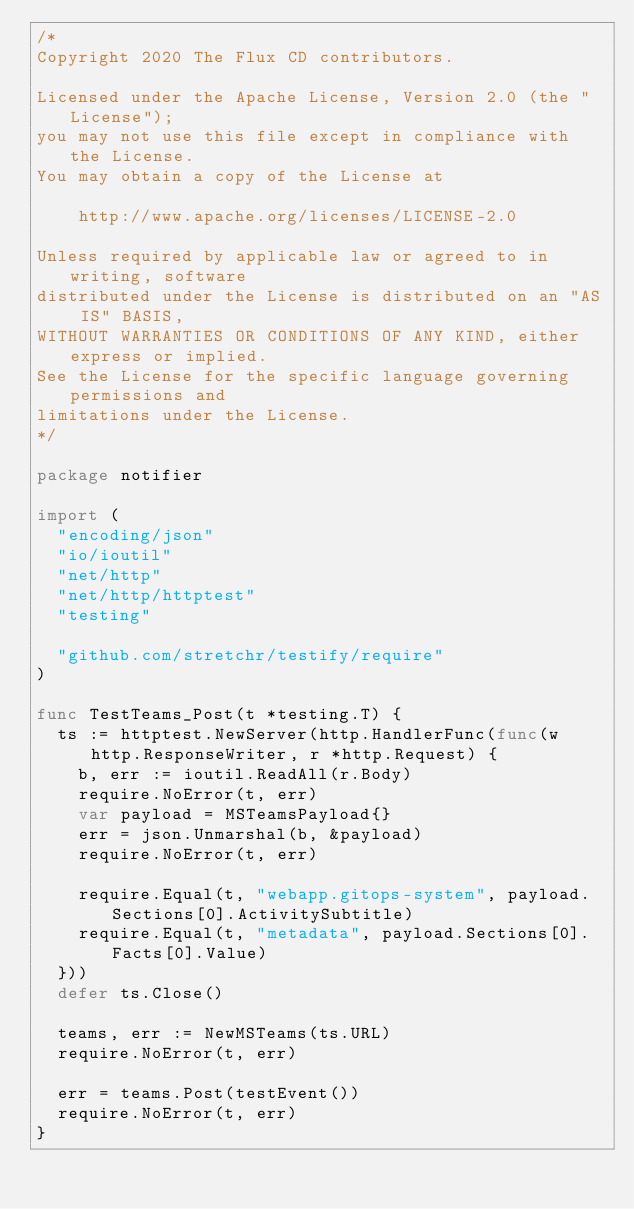Convert code to text. <code><loc_0><loc_0><loc_500><loc_500><_Go_>/*
Copyright 2020 The Flux CD contributors.

Licensed under the Apache License, Version 2.0 (the "License");
you may not use this file except in compliance with the License.
You may obtain a copy of the License at

    http://www.apache.org/licenses/LICENSE-2.0

Unless required by applicable law or agreed to in writing, software
distributed under the License is distributed on an "AS IS" BASIS,
WITHOUT WARRANTIES OR CONDITIONS OF ANY KIND, either express or implied.
See the License for the specific language governing permissions and
limitations under the License.
*/

package notifier

import (
	"encoding/json"
	"io/ioutil"
	"net/http"
	"net/http/httptest"
	"testing"

	"github.com/stretchr/testify/require"
)

func TestTeams_Post(t *testing.T) {
	ts := httptest.NewServer(http.HandlerFunc(func(w http.ResponseWriter, r *http.Request) {
		b, err := ioutil.ReadAll(r.Body)
		require.NoError(t, err)
		var payload = MSTeamsPayload{}
		err = json.Unmarshal(b, &payload)
		require.NoError(t, err)

		require.Equal(t, "webapp.gitops-system", payload.Sections[0].ActivitySubtitle)
		require.Equal(t, "metadata", payload.Sections[0].Facts[0].Value)
	}))
	defer ts.Close()

	teams, err := NewMSTeams(ts.URL)
	require.NoError(t, err)

	err = teams.Post(testEvent())
	require.NoError(t, err)
}
</code> 